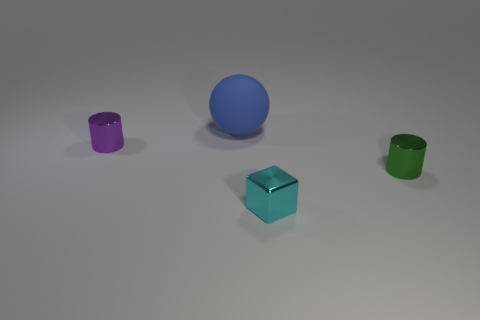Are there more tiny shiny blocks in front of the purple metallic cylinder than gray metal cylinders?
Offer a terse response. Yes. What number of spheres are either brown rubber objects or blue matte objects?
Provide a short and direct response. 1. What shape is the tiny metallic thing that is both to the right of the small purple metal thing and behind the cyan cube?
Offer a very short reply. Cylinder. Is the number of metallic cylinders that are in front of the green cylinder the same as the number of small cyan metallic objects that are left of the large blue object?
Your answer should be compact. Yes. How many objects are blue cylinders or small metallic cylinders?
Make the answer very short. 2. What color is the cylinder that is the same size as the green thing?
Your answer should be very brief. Purple. What number of objects are objects in front of the large blue sphere or objects that are on the left side of the small cyan metallic object?
Your response must be concise. 4. Are there the same number of blue matte objects that are to the left of the large blue thing and green matte spheres?
Keep it short and to the point. Yes. There is a shiny cylinder that is right of the cyan object; does it have the same size as the thing behind the tiny purple metal object?
Offer a very short reply. No. How many other things are there of the same size as the cyan metallic thing?
Offer a terse response. 2. 